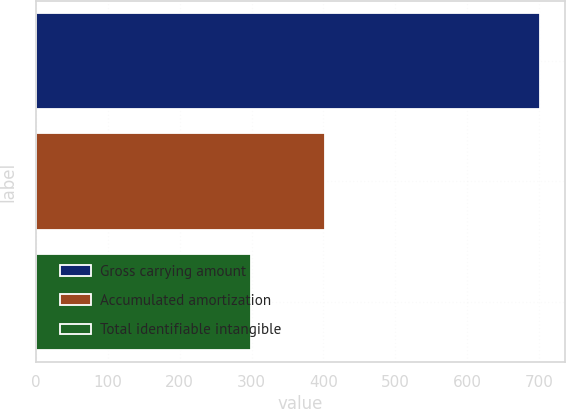<chart> <loc_0><loc_0><loc_500><loc_500><bar_chart><fcel>Gross carrying amount<fcel>Accumulated amortization<fcel>Total identifiable intangible<nl><fcel>700.4<fcel>401.4<fcel>299<nl></chart> 